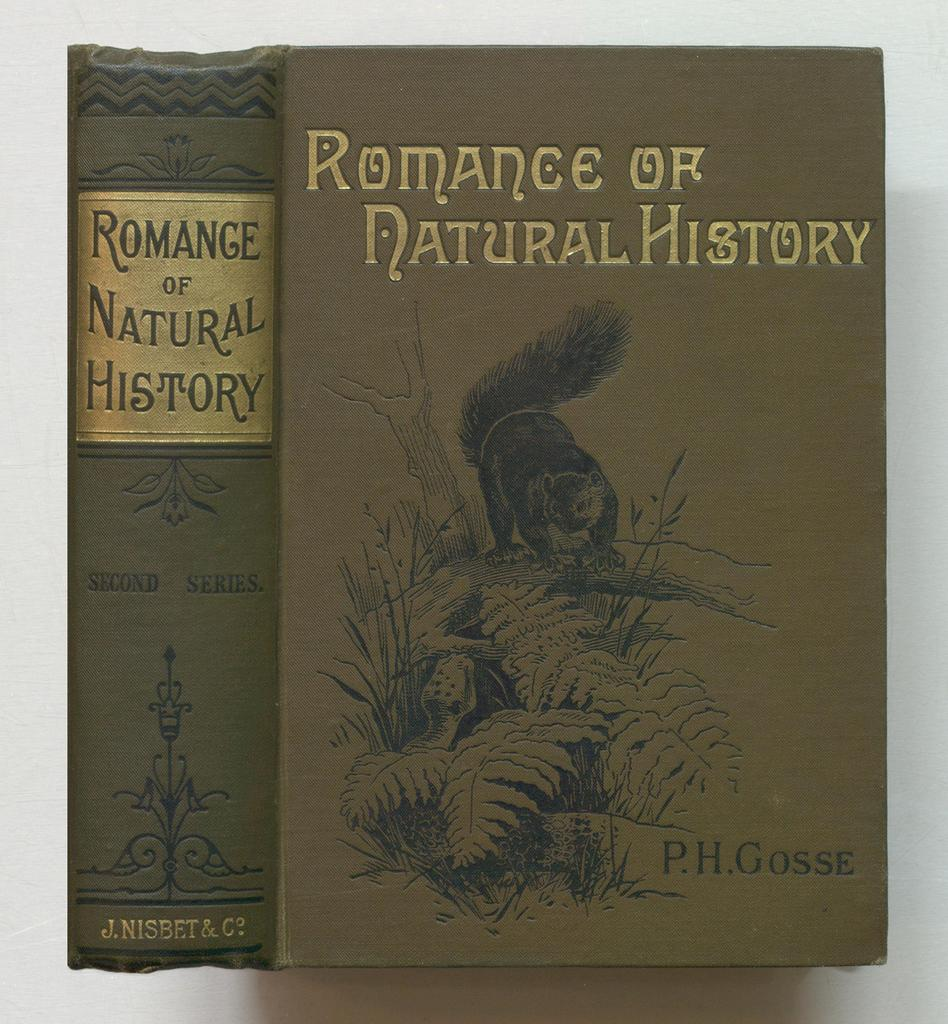<image>
Provide a brief description of the given image. A book called the Romance of Natural History has a squa 